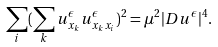<formula> <loc_0><loc_0><loc_500><loc_500>\sum _ { i } ( \sum _ { k } u _ { x _ { k } } ^ { \epsilon } u _ { x _ { k } x _ { i } } ^ { \epsilon } ) ^ { 2 } = \mu ^ { 2 } | D u ^ { \epsilon } | ^ { 4 } .</formula> 